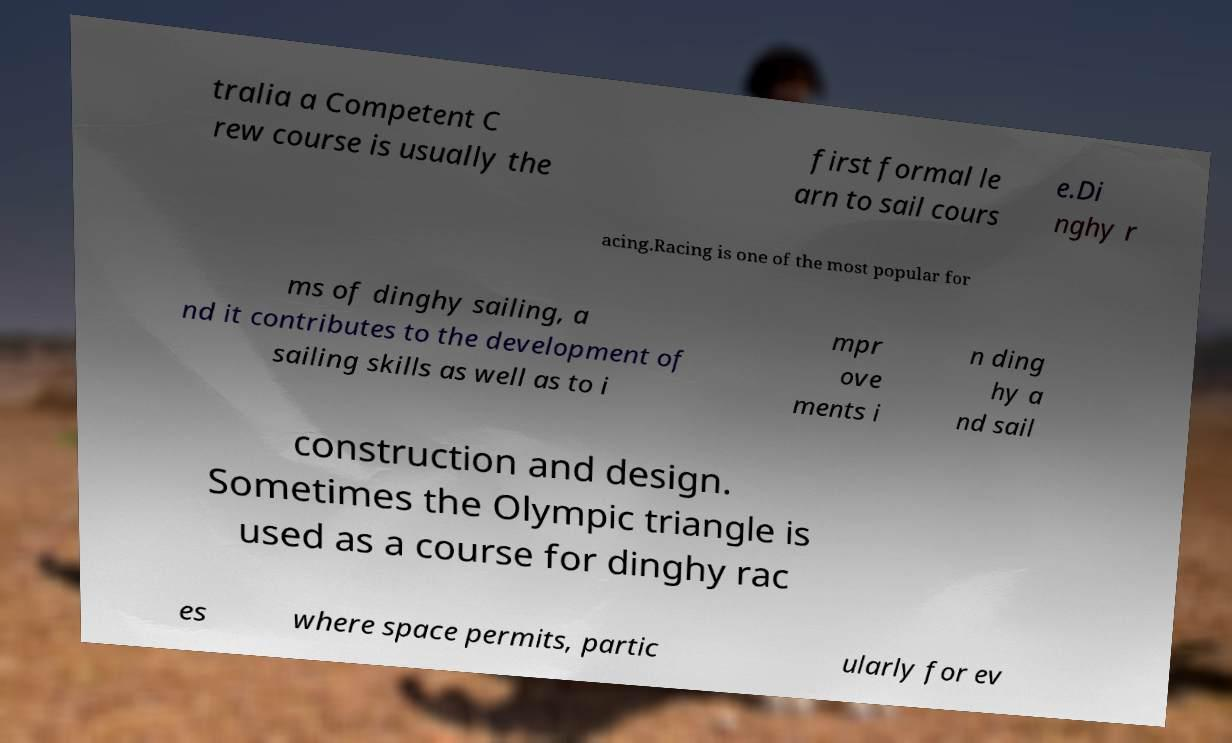Could you extract and type out the text from this image? tralia a Competent C rew course is usually the first formal le arn to sail cours e.Di nghy r acing.Racing is one of the most popular for ms of dinghy sailing, a nd it contributes to the development of sailing skills as well as to i mpr ove ments i n ding hy a nd sail construction and design. Sometimes the Olympic triangle is used as a course for dinghy rac es where space permits, partic ularly for ev 